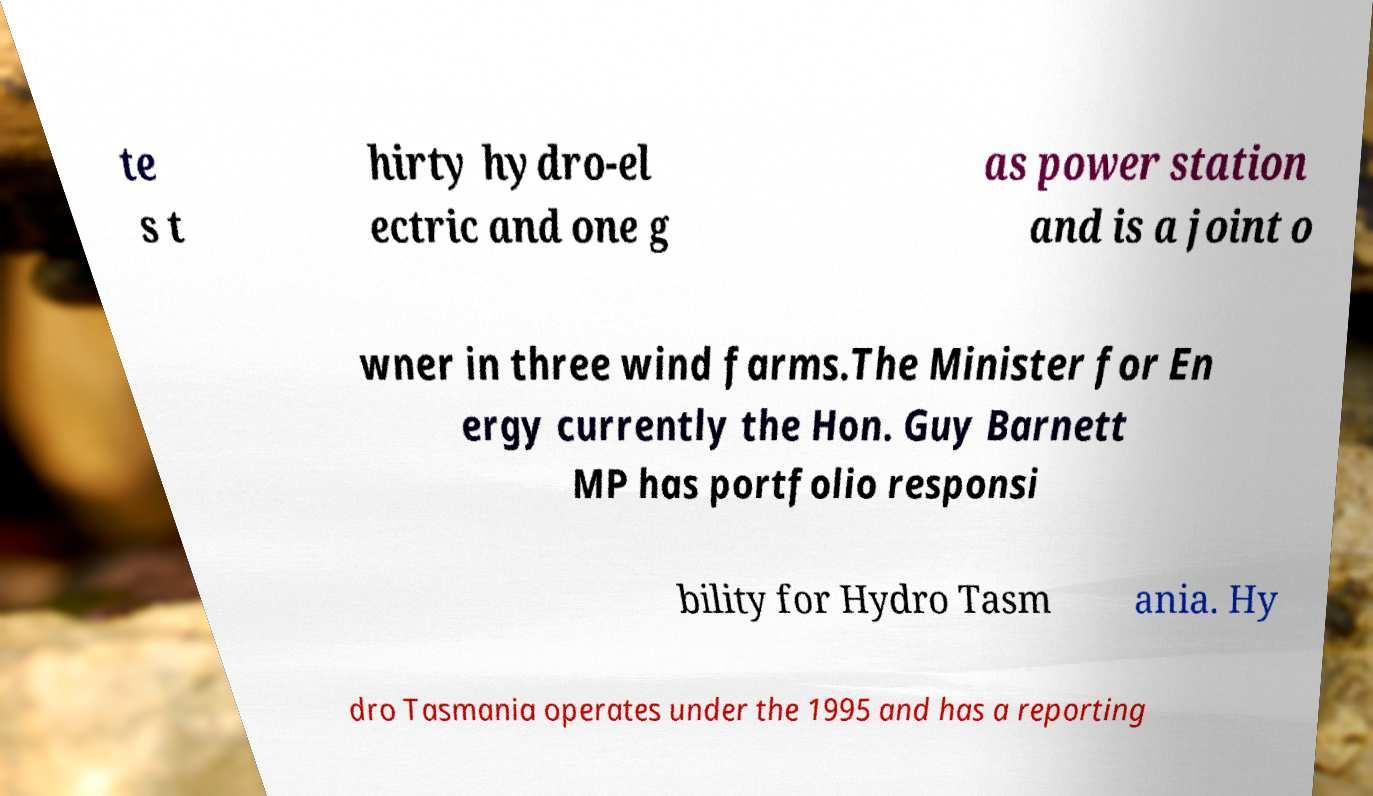Can you accurately transcribe the text from the provided image for me? te s t hirty hydro-el ectric and one g as power station and is a joint o wner in three wind farms.The Minister for En ergy currently the Hon. Guy Barnett MP has portfolio responsi bility for Hydro Tasm ania. Hy dro Tasmania operates under the 1995 and has a reporting 